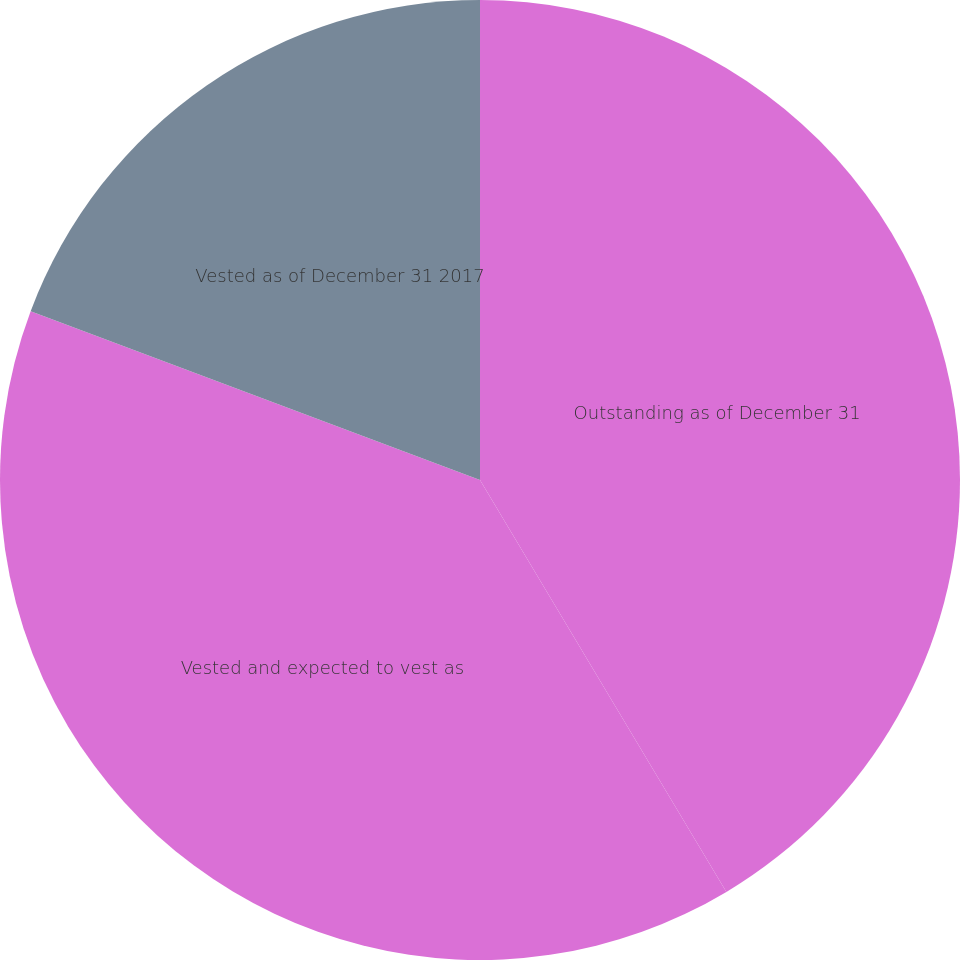Convert chart to OTSL. <chart><loc_0><loc_0><loc_500><loc_500><pie_chart><fcel>Outstanding as of December 31<fcel>Vested and expected to vest as<fcel>Vested as of December 31 2017<nl><fcel>41.42%<fcel>39.3%<fcel>19.28%<nl></chart> 